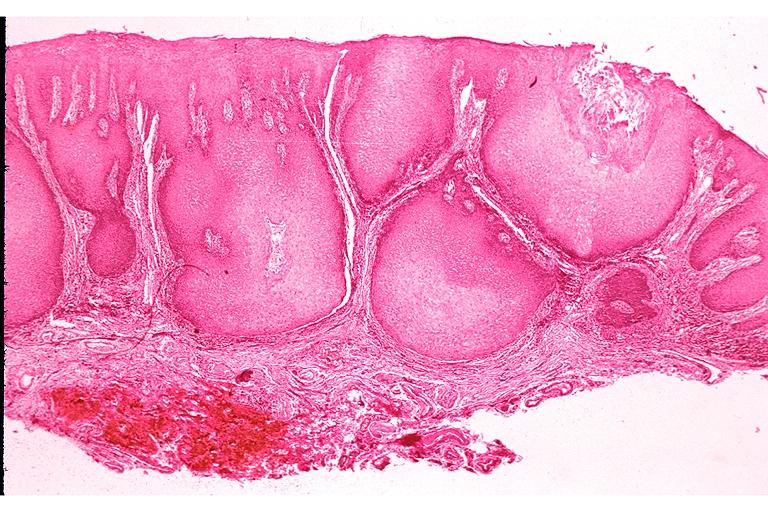does opened base of skull with brain show verrucous carcinoma?
Answer the question using a single word or phrase. No 